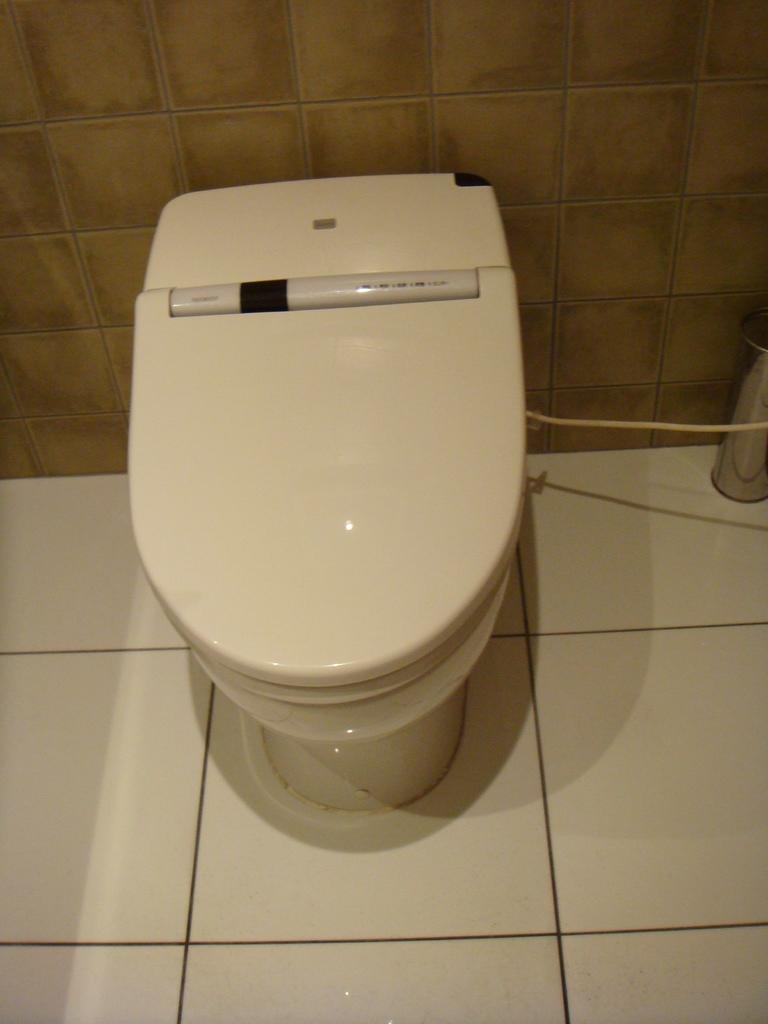What is the main object in the image? There is a toilet seat in the image. Where is the toilet seat located in relation to other objects or surfaces? The toilet seat is in front of a wall. What type of cake is being served by the man in the image? There is no man or cake present in the image; it only features a toilet seat in front of a wall. 